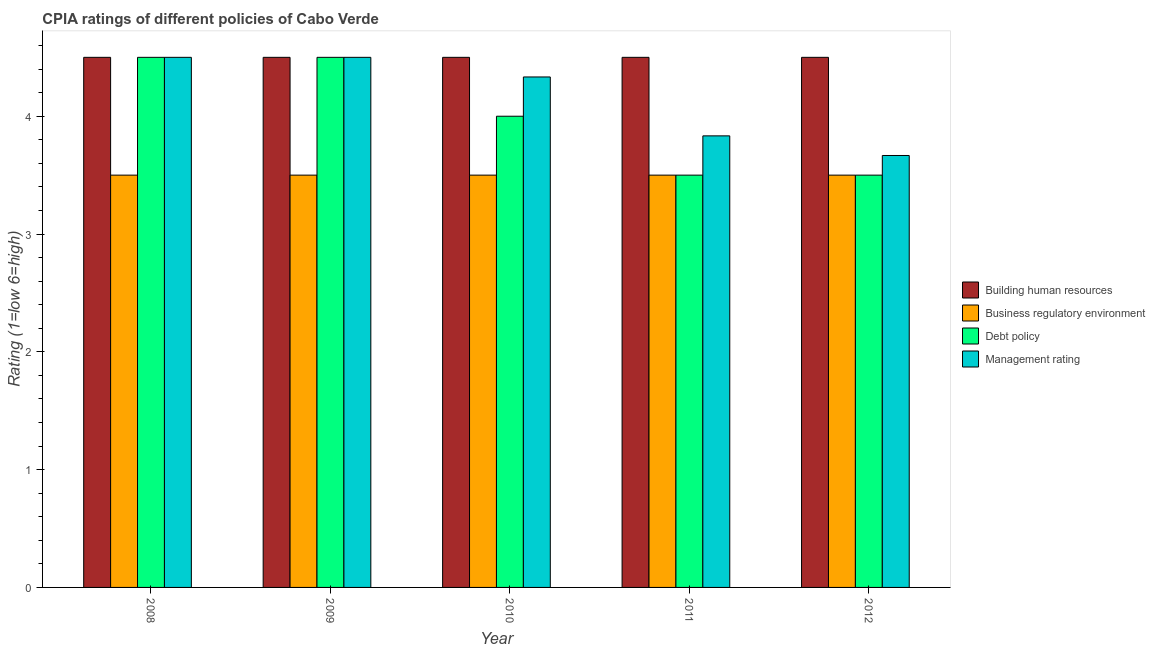How many groups of bars are there?
Make the answer very short. 5. Are the number of bars per tick equal to the number of legend labels?
Make the answer very short. Yes. In how many cases, is the number of bars for a given year not equal to the number of legend labels?
Ensure brevity in your answer.  0. What is the cpia rating of management in 2008?
Ensure brevity in your answer.  4.5. In which year was the cpia rating of management maximum?
Provide a short and direct response. 2008. What is the total cpia rating of debt policy in the graph?
Make the answer very short. 20. What is the average cpia rating of management per year?
Your response must be concise. 4.17. In how many years, is the cpia rating of building human resources greater than 0.6000000000000001?
Offer a terse response. 5. What is the ratio of the cpia rating of management in 2009 to that in 2010?
Make the answer very short. 1.04. What is the difference between the highest and the second highest cpia rating of debt policy?
Make the answer very short. 0. What is the difference between the highest and the lowest cpia rating of management?
Your answer should be compact. 0.83. In how many years, is the cpia rating of management greater than the average cpia rating of management taken over all years?
Ensure brevity in your answer.  3. Is the sum of the cpia rating of business regulatory environment in 2008 and 2009 greater than the maximum cpia rating of management across all years?
Your answer should be compact. Yes. Is it the case that in every year, the sum of the cpia rating of management and cpia rating of debt policy is greater than the sum of cpia rating of business regulatory environment and cpia rating of building human resources?
Provide a succinct answer. No. What does the 1st bar from the left in 2011 represents?
Make the answer very short. Building human resources. What does the 1st bar from the right in 2011 represents?
Keep it short and to the point. Management rating. Is it the case that in every year, the sum of the cpia rating of building human resources and cpia rating of business regulatory environment is greater than the cpia rating of debt policy?
Provide a succinct answer. Yes. Are all the bars in the graph horizontal?
Give a very brief answer. No. What is the difference between two consecutive major ticks on the Y-axis?
Ensure brevity in your answer.  1. Are the values on the major ticks of Y-axis written in scientific E-notation?
Offer a very short reply. No. Does the graph contain grids?
Ensure brevity in your answer.  No. Where does the legend appear in the graph?
Your answer should be very brief. Center right. How many legend labels are there?
Your response must be concise. 4. How are the legend labels stacked?
Make the answer very short. Vertical. What is the title of the graph?
Ensure brevity in your answer.  CPIA ratings of different policies of Cabo Verde. What is the label or title of the X-axis?
Make the answer very short. Year. What is the label or title of the Y-axis?
Your response must be concise. Rating (1=low 6=high). What is the Rating (1=low 6=high) of Building human resources in 2008?
Make the answer very short. 4.5. What is the Rating (1=low 6=high) in Building human resources in 2009?
Keep it short and to the point. 4.5. What is the Rating (1=low 6=high) in Debt policy in 2009?
Make the answer very short. 4.5. What is the Rating (1=low 6=high) in Building human resources in 2010?
Provide a short and direct response. 4.5. What is the Rating (1=low 6=high) in Business regulatory environment in 2010?
Offer a very short reply. 3.5. What is the Rating (1=low 6=high) of Debt policy in 2010?
Give a very brief answer. 4. What is the Rating (1=low 6=high) in Management rating in 2010?
Make the answer very short. 4.33. What is the Rating (1=low 6=high) in Business regulatory environment in 2011?
Your answer should be very brief. 3.5. What is the Rating (1=low 6=high) of Management rating in 2011?
Give a very brief answer. 3.83. What is the Rating (1=low 6=high) of Building human resources in 2012?
Your response must be concise. 4.5. What is the Rating (1=low 6=high) of Business regulatory environment in 2012?
Provide a succinct answer. 3.5. What is the Rating (1=low 6=high) in Management rating in 2012?
Keep it short and to the point. 3.67. Across all years, what is the maximum Rating (1=low 6=high) in Business regulatory environment?
Offer a terse response. 3.5. Across all years, what is the minimum Rating (1=low 6=high) of Business regulatory environment?
Ensure brevity in your answer.  3.5. Across all years, what is the minimum Rating (1=low 6=high) of Management rating?
Offer a very short reply. 3.67. What is the total Rating (1=low 6=high) of Business regulatory environment in the graph?
Provide a short and direct response. 17.5. What is the total Rating (1=low 6=high) in Management rating in the graph?
Ensure brevity in your answer.  20.83. What is the difference between the Rating (1=low 6=high) in Building human resources in 2008 and that in 2009?
Your answer should be very brief. 0. What is the difference between the Rating (1=low 6=high) of Debt policy in 2008 and that in 2009?
Keep it short and to the point. 0. What is the difference between the Rating (1=low 6=high) in Management rating in 2008 and that in 2009?
Your answer should be very brief. 0. What is the difference between the Rating (1=low 6=high) of Building human resources in 2008 and that in 2010?
Ensure brevity in your answer.  0. What is the difference between the Rating (1=low 6=high) in Debt policy in 2008 and that in 2010?
Make the answer very short. 0.5. What is the difference between the Rating (1=low 6=high) of Management rating in 2008 and that in 2010?
Give a very brief answer. 0.17. What is the difference between the Rating (1=low 6=high) in Business regulatory environment in 2008 and that in 2011?
Provide a short and direct response. 0. What is the difference between the Rating (1=low 6=high) in Debt policy in 2008 and that in 2011?
Offer a very short reply. 1. What is the difference between the Rating (1=low 6=high) in Building human resources in 2008 and that in 2012?
Your answer should be very brief. 0. What is the difference between the Rating (1=low 6=high) in Business regulatory environment in 2008 and that in 2012?
Offer a terse response. 0. What is the difference between the Rating (1=low 6=high) of Management rating in 2008 and that in 2012?
Keep it short and to the point. 0.83. What is the difference between the Rating (1=low 6=high) of Building human resources in 2009 and that in 2010?
Your answer should be very brief. 0. What is the difference between the Rating (1=low 6=high) of Debt policy in 2009 and that in 2010?
Your answer should be compact. 0.5. What is the difference between the Rating (1=low 6=high) of Building human resources in 2009 and that in 2011?
Provide a short and direct response. 0. What is the difference between the Rating (1=low 6=high) in Business regulatory environment in 2009 and that in 2011?
Keep it short and to the point. 0. What is the difference between the Rating (1=low 6=high) of Debt policy in 2009 and that in 2011?
Give a very brief answer. 1. What is the difference between the Rating (1=low 6=high) in Management rating in 2009 and that in 2011?
Provide a succinct answer. 0.67. What is the difference between the Rating (1=low 6=high) of Building human resources in 2009 and that in 2012?
Offer a terse response. 0. What is the difference between the Rating (1=low 6=high) of Business regulatory environment in 2009 and that in 2012?
Keep it short and to the point. 0. What is the difference between the Rating (1=low 6=high) in Management rating in 2009 and that in 2012?
Offer a very short reply. 0.83. What is the difference between the Rating (1=low 6=high) of Business regulatory environment in 2010 and that in 2011?
Make the answer very short. 0. What is the difference between the Rating (1=low 6=high) of Management rating in 2010 and that in 2011?
Offer a terse response. 0.5. What is the difference between the Rating (1=low 6=high) of Building human resources in 2010 and that in 2012?
Provide a succinct answer. 0. What is the difference between the Rating (1=low 6=high) in Business regulatory environment in 2010 and that in 2012?
Your answer should be very brief. 0. What is the difference between the Rating (1=low 6=high) of Building human resources in 2011 and that in 2012?
Your response must be concise. 0. What is the difference between the Rating (1=low 6=high) in Management rating in 2011 and that in 2012?
Your answer should be compact. 0.17. What is the difference between the Rating (1=low 6=high) of Building human resources in 2008 and the Rating (1=low 6=high) of Business regulatory environment in 2009?
Offer a terse response. 1. What is the difference between the Rating (1=low 6=high) in Building human resources in 2008 and the Rating (1=low 6=high) in Management rating in 2009?
Keep it short and to the point. 0. What is the difference between the Rating (1=low 6=high) in Business regulatory environment in 2008 and the Rating (1=low 6=high) in Management rating in 2009?
Make the answer very short. -1. What is the difference between the Rating (1=low 6=high) in Debt policy in 2008 and the Rating (1=low 6=high) in Management rating in 2009?
Make the answer very short. 0. What is the difference between the Rating (1=low 6=high) in Building human resources in 2008 and the Rating (1=low 6=high) in Business regulatory environment in 2010?
Provide a short and direct response. 1. What is the difference between the Rating (1=low 6=high) in Building human resources in 2008 and the Rating (1=low 6=high) in Debt policy in 2010?
Make the answer very short. 0.5. What is the difference between the Rating (1=low 6=high) in Building human resources in 2008 and the Rating (1=low 6=high) in Management rating in 2010?
Offer a terse response. 0.17. What is the difference between the Rating (1=low 6=high) in Business regulatory environment in 2008 and the Rating (1=low 6=high) in Management rating in 2010?
Give a very brief answer. -0.83. What is the difference between the Rating (1=low 6=high) of Debt policy in 2008 and the Rating (1=low 6=high) of Management rating in 2010?
Offer a very short reply. 0.17. What is the difference between the Rating (1=low 6=high) in Building human resources in 2008 and the Rating (1=low 6=high) in Business regulatory environment in 2011?
Ensure brevity in your answer.  1. What is the difference between the Rating (1=low 6=high) of Building human resources in 2008 and the Rating (1=low 6=high) of Debt policy in 2011?
Your answer should be compact. 1. What is the difference between the Rating (1=low 6=high) in Building human resources in 2008 and the Rating (1=low 6=high) in Management rating in 2011?
Make the answer very short. 0.67. What is the difference between the Rating (1=low 6=high) of Business regulatory environment in 2008 and the Rating (1=low 6=high) of Management rating in 2011?
Provide a succinct answer. -0.33. What is the difference between the Rating (1=low 6=high) of Debt policy in 2008 and the Rating (1=low 6=high) of Management rating in 2011?
Your answer should be compact. 0.67. What is the difference between the Rating (1=low 6=high) in Building human resources in 2008 and the Rating (1=low 6=high) in Management rating in 2012?
Offer a very short reply. 0.83. What is the difference between the Rating (1=low 6=high) in Business regulatory environment in 2008 and the Rating (1=low 6=high) in Management rating in 2012?
Give a very brief answer. -0.17. What is the difference between the Rating (1=low 6=high) in Debt policy in 2008 and the Rating (1=low 6=high) in Management rating in 2012?
Offer a terse response. 0.83. What is the difference between the Rating (1=low 6=high) in Building human resources in 2009 and the Rating (1=low 6=high) in Debt policy in 2010?
Make the answer very short. 0.5. What is the difference between the Rating (1=low 6=high) in Business regulatory environment in 2009 and the Rating (1=low 6=high) in Debt policy in 2010?
Offer a very short reply. -0.5. What is the difference between the Rating (1=low 6=high) of Debt policy in 2009 and the Rating (1=low 6=high) of Management rating in 2010?
Offer a terse response. 0.17. What is the difference between the Rating (1=low 6=high) in Building human resources in 2009 and the Rating (1=low 6=high) in Business regulatory environment in 2011?
Provide a succinct answer. 1. What is the difference between the Rating (1=low 6=high) in Business regulatory environment in 2009 and the Rating (1=low 6=high) in Debt policy in 2011?
Provide a short and direct response. 0. What is the difference between the Rating (1=low 6=high) of Building human resources in 2009 and the Rating (1=low 6=high) of Business regulatory environment in 2012?
Your response must be concise. 1. What is the difference between the Rating (1=low 6=high) in Building human resources in 2009 and the Rating (1=low 6=high) in Management rating in 2012?
Offer a terse response. 0.83. What is the difference between the Rating (1=low 6=high) in Business regulatory environment in 2009 and the Rating (1=low 6=high) in Management rating in 2012?
Make the answer very short. -0.17. What is the difference between the Rating (1=low 6=high) of Debt policy in 2009 and the Rating (1=low 6=high) of Management rating in 2012?
Ensure brevity in your answer.  0.83. What is the difference between the Rating (1=low 6=high) in Building human resources in 2010 and the Rating (1=low 6=high) in Business regulatory environment in 2011?
Offer a very short reply. 1. What is the difference between the Rating (1=low 6=high) in Building human resources in 2010 and the Rating (1=low 6=high) in Management rating in 2011?
Your answer should be compact. 0.67. What is the difference between the Rating (1=low 6=high) of Business regulatory environment in 2010 and the Rating (1=low 6=high) of Management rating in 2011?
Your answer should be very brief. -0.33. What is the difference between the Rating (1=low 6=high) in Building human resources in 2010 and the Rating (1=low 6=high) in Debt policy in 2012?
Your response must be concise. 1. What is the difference between the Rating (1=low 6=high) of Building human resources in 2010 and the Rating (1=low 6=high) of Management rating in 2012?
Make the answer very short. 0.83. What is the difference between the Rating (1=low 6=high) in Business regulatory environment in 2010 and the Rating (1=low 6=high) in Debt policy in 2012?
Keep it short and to the point. 0. What is the difference between the Rating (1=low 6=high) of Business regulatory environment in 2010 and the Rating (1=low 6=high) of Management rating in 2012?
Your answer should be compact. -0.17. What is the difference between the Rating (1=low 6=high) of Debt policy in 2010 and the Rating (1=low 6=high) of Management rating in 2012?
Provide a succinct answer. 0.33. What is the difference between the Rating (1=low 6=high) in Building human resources in 2011 and the Rating (1=low 6=high) in Business regulatory environment in 2012?
Give a very brief answer. 1. What is the difference between the Rating (1=low 6=high) of Building human resources in 2011 and the Rating (1=low 6=high) of Management rating in 2012?
Your answer should be very brief. 0.83. What is the difference between the Rating (1=low 6=high) in Business regulatory environment in 2011 and the Rating (1=low 6=high) in Debt policy in 2012?
Make the answer very short. 0. What is the average Rating (1=low 6=high) of Building human resources per year?
Offer a terse response. 4.5. What is the average Rating (1=low 6=high) in Debt policy per year?
Give a very brief answer. 4. What is the average Rating (1=low 6=high) of Management rating per year?
Your answer should be compact. 4.17. In the year 2008, what is the difference between the Rating (1=low 6=high) in Building human resources and Rating (1=low 6=high) in Business regulatory environment?
Make the answer very short. 1. In the year 2008, what is the difference between the Rating (1=low 6=high) in Business regulatory environment and Rating (1=low 6=high) in Management rating?
Your answer should be compact. -1. In the year 2009, what is the difference between the Rating (1=low 6=high) in Building human resources and Rating (1=low 6=high) in Business regulatory environment?
Your response must be concise. 1. In the year 2009, what is the difference between the Rating (1=low 6=high) of Building human resources and Rating (1=low 6=high) of Management rating?
Your answer should be compact. 0. In the year 2009, what is the difference between the Rating (1=low 6=high) in Business regulatory environment and Rating (1=low 6=high) in Debt policy?
Provide a succinct answer. -1. In the year 2009, what is the difference between the Rating (1=low 6=high) of Debt policy and Rating (1=low 6=high) of Management rating?
Make the answer very short. 0. In the year 2010, what is the difference between the Rating (1=low 6=high) in Building human resources and Rating (1=low 6=high) in Business regulatory environment?
Offer a terse response. 1. In the year 2010, what is the difference between the Rating (1=low 6=high) of Building human resources and Rating (1=low 6=high) of Debt policy?
Provide a short and direct response. 0.5. In the year 2010, what is the difference between the Rating (1=low 6=high) in Building human resources and Rating (1=low 6=high) in Management rating?
Your response must be concise. 0.17. In the year 2010, what is the difference between the Rating (1=low 6=high) of Business regulatory environment and Rating (1=low 6=high) of Management rating?
Offer a terse response. -0.83. In the year 2011, what is the difference between the Rating (1=low 6=high) in Building human resources and Rating (1=low 6=high) in Business regulatory environment?
Offer a terse response. 1. In the year 2011, what is the difference between the Rating (1=low 6=high) in Building human resources and Rating (1=low 6=high) in Debt policy?
Offer a terse response. 1. In the year 2011, what is the difference between the Rating (1=low 6=high) of Building human resources and Rating (1=low 6=high) of Management rating?
Provide a short and direct response. 0.67. In the year 2011, what is the difference between the Rating (1=low 6=high) in Business regulatory environment and Rating (1=low 6=high) in Debt policy?
Provide a short and direct response. 0. In the year 2012, what is the difference between the Rating (1=low 6=high) in Building human resources and Rating (1=low 6=high) in Business regulatory environment?
Your answer should be very brief. 1. In the year 2012, what is the difference between the Rating (1=low 6=high) of Building human resources and Rating (1=low 6=high) of Debt policy?
Make the answer very short. 1. What is the ratio of the Rating (1=low 6=high) in Building human resources in 2008 to that in 2009?
Offer a very short reply. 1. What is the ratio of the Rating (1=low 6=high) of Business regulatory environment in 2008 to that in 2009?
Offer a very short reply. 1. What is the ratio of the Rating (1=low 6=high) of Debt policy in 2008 to that in 2009?
Give a very brief answer. 1. What is the ratio of the Rating (1=low 6=high) of Management rating in 2008 to that in 2010?
Your response must be concise. 1.04. What is the ratio of the Rating (1=low 6=high) of Building human resources in 2008 to that in 2011?
Keep it short and to the point. 1. What is the ratio of the Rating (1=low 6=high) in Debt policy in 2008 to that in 2011?
Offer a terse response. 1.29. What is the ratio of the Rating (1=low 6=high) of Management rating in 2008 to that in 2011?
Provide a succinct answer. 1.17. What is the ratio of the Rating (1=low 6=high) in Business regulatory environment in 2008 to that in 2012?
Your response must be concise. 1. What is the ratio of the Rating (1=low 6=high) of Management rating in 2008 to that in 2012?
Offer a terse response. 1.23. What is the ratio of the Rating (1=low 6=high) of Business regulatory environment in 2009 to that in 2010?
Offer a terse response. 1. What is the ratio of the Rating (1=low 6=high) in Debt policy in 2009 to that in 2010?
Offer a terse response. 1.12. What is the ratio of the Rating (1=low 6=high) in Business regulatory environment in 2009 to that in 2011?
Give a very brief answer. 1. What is the ratio of the Rating (1=low 6=high) in Management rating in 2009 to that in 2011?
Your answer should be very brief. 1.17. What is the ratio of the Rating (1=low 6=high) in Building human resources in 2009 to that in 2012?
Give a very brief answer. 1. What is the ratio of the Rating (1=low 6=high) in Management rating in 2009 to that in 2012?
Your answer should be very brief. 1.23. What is the ratio of the Rating (1=low 6=high) of Debt policy in 2010 to that in 2011?
Keep it short and to the point. 1.14. What is the ratio of the Rating (1=low 6=high) in Management rating in 2010 to that in 2011?
Your answer should be very brief. 1.13. What is the ratio of the Rating (1=low 6=high) in Building human resources in 2010 to that in 2012?
Make the answer very short. 1. What is the ratio of the Rating (1=low 6=high) of Management rating in 2010 to that in 2012?
Make the answer very short. 1.18. What is the ratio of the Rating (1=low 6=high) in Management rating in 2011 to that in 2012?
Your answer should be very brief. 1.05. What is the difference between the highest and the second highest Rating (1=low 6=high) in Building human resources?
Your answer should be very brief. 0. What is the difference between the highest and the lowest Rating (1=low 6=high) in Business regulatory environment?
Keep it short and to the point. 0. What is the difference between the highest and the lowest Rating (1=low 6=high) of Debt policy?
Ensure brevity in your answer.  1. What is the difference between the highest and the lowest Rating (1=low 6=high) of Management rating?
Your response must be concise. 0.83. 